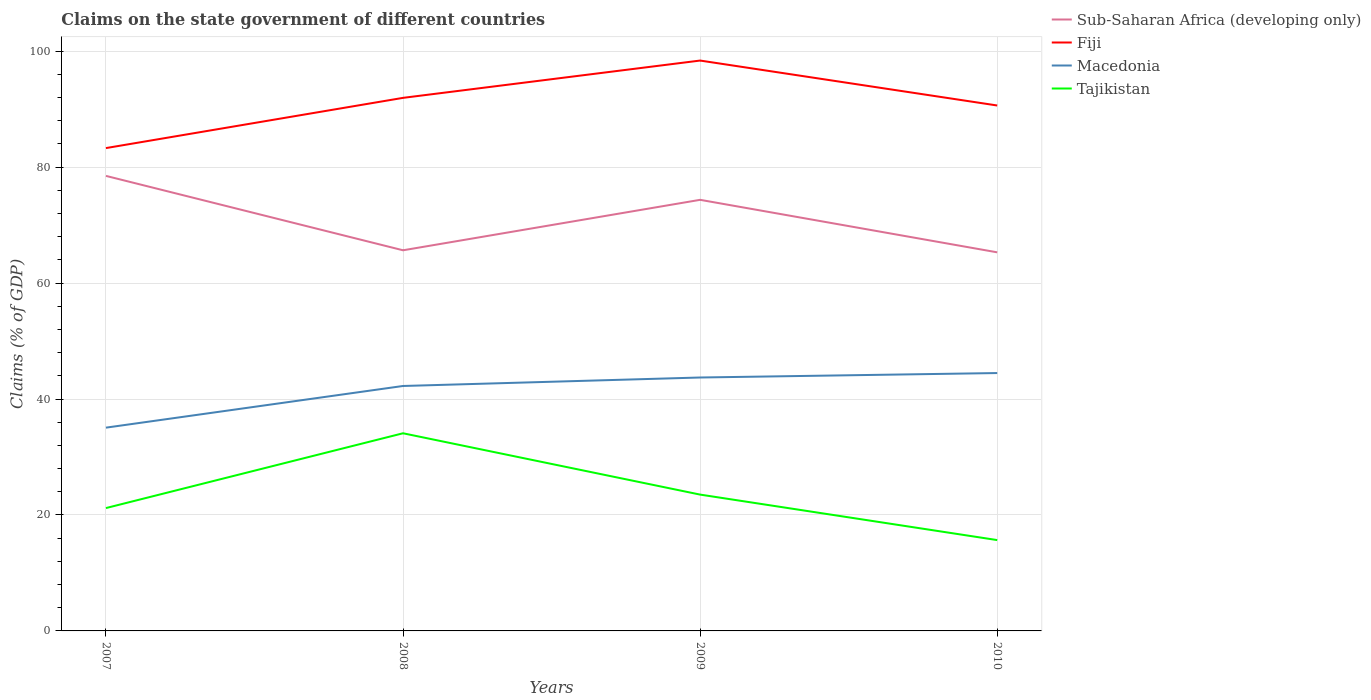Does the line corresponding to Macedonia intersect with the line corresponding to Tajikistan?
Your answer should be very brief. No. Across all years, what is the maximum percentage of GDP claimed on the state government in Fiji?
Offer a terse response. 83.28. What is the total percentage of GDP claimed on the state government in Sub-Saharan Africa (developing only) in the graph?
Give a very brief answer. 13.18. What is the difference between the highest and the second highest percentage of GDP claimed on the state government in Fiji?
Ensure brevity in your answer.  15.1. Is the percentage of GDP claimed on the state government in Fiji strictly greater than the percentage of GDP claimed on the state government in Macedonia over the years?
Provide a short and direct response. No. How many years are there in the graph?
Provide a short and direct response. 4. What is the difference between two consecutive major ticks on the Y-axis?
Offer a terse response. 20. Are the values on the major ticks of Y-axis written in scientific E-notation?
Provide a short and direct response. No. Does the graph contain any zero values?
Keep it short and to the point. No. Where does the legend appear in the graph?
Make the answer very short. Top right. How are the legend labels stacked?
Ensure brevity in your answer.  Vertical. What is the title of the graph?
Offer a very short reply. Claims on the state government of different countries. Does "Barbados" appear as one of the legend labels in the graph?
Your answer should be very brief. No. What is the label or title of the X-axis?
Your answer should be compact. Years. What is the label or title of the Y-axis?
Your answer should be very brief. Claims (% of GDP). What is the Claims (% of GDP) of Sub-Saharan Africa (developing only) in 2007?
Your answer should be compact. 78.48. What is the Claims (% of GDP) in Fiji in 2007?
Make the answer very short. 83.28. What is the Claims (% of GDP) in Macedonia in 2007?
Your answer should be compact. 35.06. What is the Claims (% of GDP) of Tajikistan in 2007?
Provide a succinct answer. 21.19. What is the Claims (% of GDP) in Sub-Saharan Africa (developing only) in 2008?
Give a very brief answer. 65.65. What is the Claims (% of GDP) of Fiji in 2008?
Keep it short and to the point. 91.94. What is the Claims (% of GDP) in Macedonia in 2008?
Make the answer very short. 42.25. What is the Claims (% of GDP) of Tajikistan in 2008?
Your answer should be very brief. 34.09. What is the Claims (% of GDP) of Sub-Saharan Africa (developing only) in 2009?
Keep it short and to the point. 74.35. What is the Claims (% of GDP) of Fiji in 2009?
Offer a terse response. 98.38. What is the Claims (% of GDP) in Macedonia in 2009?
Keep it short and to the point. 43.71. What is the Claims (% of GDP) in Tajikistan in 2009?
Your answer should be compact. 23.51. What is the Claims (% of GDP) of Sub-Saharan Africa (developing only) in 2010?
Provide a short and direct response. 65.3. What is the Claims (% of GDP) in Fiji in 2010?
Ensure brevity in your answer.  90.63. What is the Claims (% of GDP) of Macedonia in 2010?
Offer a terse response. 44.48. What is the Claims (% of GDP) of Tajikistan in 2010?
Keep it short and to the point. 15.67. Across all years, what is the maximum Claims (% of GDP) in Sub-Saharan Africa (developing only)?
Offer a terse response. 78.48. Across all years, what is the maximum Claims (% of GDP) of Fiji?
Give a very brief answer. 98.38. Across all years, what is the maximum Claims (% of GDP) in Macedonia?
Keep it short and to the point. 44.48. Across all years, what is the maximum Claims (% of GDP) in Tajikistan?
Your answer should be very brief. 34.09. Across all years, what is the minimum Claims (% of GDP) of Sub-Saharan Africa (developing only)?
Keep it short and to the point. 65.3. Across all years, what is the minimum Claims (% of GDP) of Fiji?
Make the answer very short. 83.28. Across all years, what is the minimum Claims (% of GDP) of Macedonia?
Your answer should be very brief. 35.06. Across all years, what is the minimum Claims (% of GDP) in Tajikistan?
Give a very brief answer. 15.67. What is the total Claims (% of GDP) of Sub-Saharan Africa (developing only) in the graph?
Provide a succinct answer. 283.79. What is the total Claims (% of GDP) in Fiji in the graph?
Your response must be concise. 364.22. What is the total Claims (% of GDP) in Macedonia in the graph?
Give a very brief answer. 165.49. What is the total Claims (% of GDP) of Tajikistan in the graph?
Ensure brevity in your answer.  94.46. What is the difference between the Claims (% of GDP) in Sub-Saharan Africa (developing only) in 2007 and that in 2008?
Provide a short and direct response. 12.83. What is the difference between the Claims (% of GDP) in Fiji in 2007 and that in 2008?
Your response must be concise. -8.66. What is the difference between the Claims (% of GDP) in Macedonia in 2007 and that in 2008?
Make the answer very short. -7.19. What is the difference between the Claims (% of GDP) in Sub-Saharan Africa (developing only) in 2007 and that in 2009?
Your answer should be compact. 4.13. What is the difference between the Claims (% of GDP) in Fiji in 2007 and that in 2009?
Offer a very short reply. -15.1. What is the difference between the Claims (% of GDP) in Macedonia in 2007 and that in 2009?
Provide a succinct answer. -8.65. What is the difference between the Claims (% of GDP) in Tajikistan in 2007 and that in 2009?
Offer a very short reply. -2.32. What is the difference between the Claims (% of GDP) in Sub-Saharan Africa (developing only) in 2007 and that in 2010?
Your answer should be very brief. 13.18. What is the difference between the Claims (% of GDP) in Fiji in 2007 and that in 2010?
Provide a succinct answer. -7.35. What is the difference between the Claims (% of GDP) of Macedonia in 2007 and that in 2010?
Make the answer very short. -9.42. What is the difference between the Claims (% of GDP) in Tajikistan in 2007 and that in 2010?
Provide a short and direct response. 5.52. What is the difference between the Claims (% of GDP) of Sub-Saharan Africa (developing only) in 2008 and that in 2009?
Keep it short and to the point. -8.7. What is the difference between the Claims (% of GDP) of Fiji in 2008 and that in 2009?
Offer a very short reply. -6.43. What is the difference between the Claims (% of GDP) of Macedonia in 2008 and that in 2009?
Offer a very short reply. -1.46. What is the difference between the Claims (% of GDP) in Tajikistan in 2008 and that in 2009?
Your answer should be compact. 10.58. What is the difference between the Claims (% of GDP) in Sub-Saharan Africa (developing only) in 2008 and that in 2010?
Your answer should be very brief. 0.35. What is the difference between the Claims (% of GDP) of Fiji in 2008 and that in 2010?
Your answer should be very brief. 1.32. What is the difference between the Claims (% of GDP) of Macedonia in 2008 and that in 2010?
Make the answer very short. -2.23. What is the difference between the Claims (% of GDP) in Tajikistan in 2008 and that in 2010?
Make the answer very short. 18.42. What is the difference between the Claims (% of GDP) in Sub-Saharan Africa (developing only) in 2009 and that in 2010?
Give a very brief answer. 9.06. What is the difference between the Claims (% of GDP) in Fiji in 2009 and that in 2010?
Your answer should be compact. 7.75. What is the difference between the Claims (% of GDP) in Macedonia in 2009 and that in 2010?
Offer a very short reply. -0.77. What is the difference between the Claims (% of GDP) of Tajikistan in 2009 and that in 2010?
Your response must be concise. 7.85. What is the difference between the Claims (% of GDP) of Sub-Saharan Africa (developing only) in 2007 and the Claims (% of GDP) of Fiji in 2008?
Give a very brief answer. -13.46. What is the difference between the Claims (% of GDP) of Sub-Saharan Africa (developing only) in 2007 and the Claims (% of GDP) of Macedonia in 2008?
Make the answer very short. 36.23. What is the difference between the Claims (% of GDP) of Sub-Saharan Africa (developing only) in 2007 and the Claims (% of GDP) of Tajikistan in 2008?
Ensure brevity in your answer.  44.39. What is the difference between the Claims (% of GDP) of Fiji in 2007 and the Claims (% of GDP) of Macedonia in 2008?
Ensure brevity in your answer.  41.03. What is the difference between the Claims (% of GDP) in Fiji in 2007 and the Claims (% of GDP) in Tajikistan in 2008?
Your answer should be compact. 49.19. What is the difference between the Claims (% of GDP) in Macedonia in 2007 and the Claims (% of GDP) in Tajikistan in 2008?
Your answer should be compact. 0.97. What is the difference between the Claims (% of GDP) of Sub-Saharan Africa (developing only) in 2007 and the Claims (% of GDP) of Fiji in 2009?
Provide a succinct answer. -19.89. What is the difference between the Claims (% of GDP) of Sub-Saharan Africa (developing only) in 2007 and the Claims (% of GDP) of Macedonia in 2009?
Your response must be concise. 34.77. What is the difference between the Claims (% of GDP) of Sub-Saharan Africa (developing only) in 2007 and the Claims (% of GDP) of Tajikistan in 2009?
Keep it short and to the point. 54.97. What is the difference between the Claims (% of GDP) of Fiji in 2007 and the Claims (% of GDP) of Macedonia in 2009?
Ensure brevity in your answer.  39.57. What is the difference between the Claims (% of GDP) in Fiji in 2007 and the Claims (% of GDP) in Tajikistan in 2009?
Provide a short and direct response. 59.77. What is the difference between the Claims (% of GDP) of Macedonia in 2007 and the Claims (% of GDP) of Tajikistan in 2009?
Keep it short and to the point. 11.55. What is the difference between the Claims (% of GDP) in Sub-Saharan Africa (developing only) in 2007 and the Claims (% of GDP) in Fiji in 2010?
Provide a succinct answer. -12.14. What is the difference between the Claims (% of GDP) of Sub-Saharan Africa (developing only) in 2007 and the Claims (% of GDP) of Macedonia in 2010?
Your response must be concise. 34. What is the difference between the Claims (% of GDP) of Sub-Saharan Africa (developing only) in 2007 and the Claims (% of GDP) of Tajikistan in 2010?
Make the answer very short. 62.81. What is the difference between the Claims (% of GDP) in Fiji in 2007 and the Claims (% of GDP) in Macedonia in 2010?
Give a very brief answer. 38.8. What is the difference between the Claims (% of GDP) of Fiji in 2007 and the Claims (% of GDP) of Tajikistan in 2010?
Your answer should be very brief. 67.61. What is the difference between the Claims (% of GDP) of Macedonia in 2007 and the Claims (% of GDP) of Tajikistan in 2010?
Provide a succinct answer. 19.39. What is the difference between the Claims (% of GDP) in Sub-Saharan Africa (developing only) in 2008 and the Claims (% of GDP) in Fiji in 2009?
Your response must be concise. -32.72. What is the difference between the Claims (% of GDP) of Sub-Saharan Africa (developing only) in 2008 and the Claims (% of GDP) of Macedonia in 2009?
Offer a terse response. 21.94. What is the difference between the Claims (% of GDP) of Sub-Saharan Africa (developing only) in 2008 and the Claims (% of GDP) of Tajikistan in 2009?
Give a very brief answer. 42.14. What is the difference between the Claims (% of GDP) of Fiji in 2008 and the Claims (% of GDP) of Macedonia in 2009?
Your answer should be compact. 48.23. What is the difference between the Claims (% of GDP) of Fiji in 2008 and the Claims (% of GDP) of Tajikistan in 2009?
Keep it short and to the point. 68.43. What is the difference between the Claims (% of GDP) of Macedonia in 2008 and the Claims (% of GDP) of Tajikistan in 2009?
Your response must be concise. 18.73. What is the difference between the Claims (% of GDP) of Sub-Saharan Africa (developing only) in 2008 and the Claims (% of GDP) of Fiji in 2010?
Your response must be concise. -24.97. What is the difference between the Claims (% of GDP) of Sub-Saharan Africa (developing only) in 2008 and the Claims (% of GDP) of Macedonia in 2010?
Ensure brevity in your answer.  21.18. What is the difference between the Claims (% of GDP) in Sub-Saharan Africa (developing only) in 2008 and the Claims (% of GDP) in Tajikistan in 2010?
Offer a terse response. 49.99. What is the difference between the Claims (% of GDP) of Fiji in 2008 and the Claims (% of GDP) of Macedonia in 2010?
Give a very brief answer. 47.46. What is the difference between the Claims (% of GDP) of Fiji in 2008 and the Claims (% of GDP) of Tajikistan in 2010?
Give a very brief answer. 76.28. What is the difference between the Claims (% of GDP) in Macedonia in 2008 and the Claims (% of GDP) in Tajikistan in 2010?
Provide a succinct answer. 26.58. What is the difference between the Claims (% of GDP) of Sub-Saharan Africa (developing only) in 2009 and the Claims (% of GDP) of Fiji in 2010?
Provide a succinct answer. -16.27. What is the difference between the Claims (% of GDP) in Sub-Saharan Africa (developing only) in 2009 and the Claims (% of GDP) in Macedonia in 2010?
Your answer should be compact. 29.88. What is the difference between the Claims (% of GDP) in Sub-Saharan Africa (developing only) in 2009 and the Claims (% of GDP) in Tajikistan in 2010?
Keep it short and to the point. 58.69. What is the difference between the Claims (% of GDP) in Fiji in 2009 and the Claims (% of GDP) in Macedonia in 2010?
Your answer should be very brief. 53.9. What is the difference between the Claims (% of GDP) of Fiji in 2009 and the Claims (% of GDP) of Tajikistan in 2010?
Provide a succinct answer. 82.71. What is the difference between the Claims (% of GDP) in Macedonia in 2009 and the Claims (% of GDP) in Tajikistan in 2010?
Offer a very short reply. 28.04. What is the average Claims (% of GDP) of Sub-Saharan Africa (developing only) per year?
Provide a succinct answer. 70.95. What is the average Claims (% of GDP) in Fiji per year?
Your response must be concise. 91.06. What is the average Claims (% of GDP) of Macedonia per year?
Your response must be concise. 41.37. What is the average Claims (% of GDP) of Tajikistan per year?
Your answer should be compact. 23.61. In the year 2007, what is the difference between the Claims (% of GDP) of Sub-Saharan Africa (developing only) and Claims (% of GDP) of Fiji?
Offer a terse response. -4.8. In the year 2007, what is the difference between the Claims (% of GDP) of Sub-Saharan Africa (developing only) and Claims (% of GDP) of Macedonia?
Provide a succinct answer. 43.42. In the year 2007, what is the difference between the Claims (% of GDP) in Sub-Saharan Africa (developing only) and Claims (% of GDP) in Tajikistan?
Your answer should be very brief. 57.29. In the year 2007, what is the difference between the Claims (% of GDP) in Fiji and Claims (% of GDP) in Macedonia?
Your answer should be compact. 48.22. In the year 2007, what is the difference between the Claims (% of GDP) of Fiji and Claims (% of GDP) of Tajikistan?
Provide a succinct answer. 62.09. In the year 2007, what is the difference between the Claims (% of GDP) in Macedonia and Claims (% of GDP) in Tajikistan?
Keep it short and to the point. 13.87. In the year 2008, what is the difference between the Claims (% of GDP) of Sub-Saharan Africa (developing only) and Claims (% of GDP) of Fiji?
Provide a short and direct response. -26.29. In the year 2008, what is the difference between the Claims (% of GDP) in Sub-Saharan Africa (developing only) and Claims (% of GDP) in Macedonia?
Provide a succinct answer. 23.41. In the year 2008, what is the difference between the Claims (% of GDP) in Sub-Saharan Africa (developing only) and Claims (% of GDP) in Tajikistan?
Provide a succinct answer. 31.56. In the year 2008, what is the difference between the Claims (% of GDP) in Fiji and Claims (% of GDP) in Macedonia?
Your answer should be compact. 49.69. In the year 2008, what is the difference between the Claims (% of GDP) of Fiji and Claims (% of GDP) of Tajikistan?
Your answer should be very brief. 57.85. In the year 2008, what is the difference between the Claims (% of GDP) of Macedonia and Claims (% of GDP) of Tajikistan?
Offer a terse response. 8.16. In the year 2009, what is the difference between the Claims (% of GDP) of Sub-Saharan Africa (developing only) and Claims (% of GDP) of Fiji?
Offer a very short reply. -24.02. In the year 2009, what is the difference between the Claims (% of GDP) of Sub-Saharan Africa (developing only) and Claims (% of GDP) of Macedonia?
Your answer should be very brief. 30.64. In the year 2009, what is the difference between the Claims (% of GDP) in Sub-Saharan Africa (developing only) and Claims (% of GDP) in Tajikistan?
Provide a succinct answer. 50.84. In the year 2009, what is the difference between the Claims (% of GDP) of Fiji and Claims (% of GDP) of Macedonia?
Your answer should be very brief. 54.67. In the year 2009, what is the difference between the Claims (% of GDP) of Fiji and Claims (% of GDP) of Tajikistan?
Give a very brief answer. 74.86. In the year 2009, what is the difference between the Claims (% of GDP) of Macedonia and Claims (% of GDP) of Tajikistan?
Your answer should be compact. 20.2. In the year 2010, what is the difference between the Claims (% of GDP) in Sub-Saharan Africa (developing only) and Claims (% of GDP) in Fiji?
Your answer should be compact. -25.33. In the year 2010, what is the difference between the Claims (% of GDP) in Sub-Saharan Africa (developing only) and Claims (% of GDP) in Macedonia?
Ensure brevity in your answer.  20.82. In the year 2010, what is the difference between the Claims (% of GDP) in Sub-Saharan Africa (developing only) and Claims (% of GDP) in Tajikistan?
Ensure brevity in your answer.  49.63. In the year 2010, what is the difference between the Claims (% of GDP) in Fiji and Claims (% of GDP) in Macedonia?
Offer a very short reply. 46.15. In the year 2010, what is the difference between the Claims (% of GDP) in Fiji and Claims (% of GDP) in Tajikistan?
Provide a short and direct response. 74.96. In the year 2010, what is the difference between the Claims (% of GDP) of Macedonia and Claims (% of GDP) of Tajikistan?
Provide a short and direct response. 28.81. What is the ratio of the Claims (% of GDP) in Sub-Saharan Africa (developing only) in 2007 to that in 2008?
Offer a terse response. 1.2. What is the ratio of the Claims (% of GDP) of Fiji in 2007 to that in 2008?
Offer a terse response. 0.91. What is the ratio of the Claims (% of GDP) in Macedonia in 2007 to that in 2008?
Make the answer very short. 0.83. What is the ratio of the Claims (% of GDP) of Tajikistan in 2007 to that in 2008?
Your answer should be compact. 0.62. What is the ratio of the Claims (% of GDP) in Sub-Saharan Africa (developing only) in 2007 to that in 2009?
Provide a short and direct response. 1.06. What is the ratio of the Claims (% of GDP) of Fiji in 2007 to that in 2009?
Your answer should be very brief. 0.85. What is the ratio of the Claims (% of GDP) of Macedonia in 2007 to that in 2009?
Offer a very short reply. 0.8. What is the ratio of the Claims (% of GDP) of Tajikistan in 2007 to that in 2009?
Ensure brevity in your answer.  0.9. What is the ratio of the Claims (% of GDP) of Sub-Saharan Africa (developing only) in 2007 to that in 2010?
Your answer should be very brief. 1.2. What is the ratio of the Claims (% of GDP) in Fiji in 2007 to that in 2010?
Offer a very short reply. 0.92. What is the ratio of the Claims (% of GDP) of Macedonia in 2007 to that in 2010?
Your answer should be compact. 0.79. What is the ratio of the Claims (% of GDP) in Tajikistan in 2007 to that in 2010?
Give a very brief answer. 1.35. What is the ratio of the Claims (% of GDP) of Sub-Saharan Africa (developing only) in 2008 to that in 2009?
Make the answer very short. 0.88. What is the ratio of the Claims (% of GDP) in Fiji in 2008 to that in 2009?
Give a very brief answer. 0.93. What is the ratio of the Claims (% of GDP) of Macedonia in 2008 to that in 2009?
Provide a succinct answer. 0.97. What is the ratio of the Claims (% of GDP) in Tajikistan in 2008 to that in 2009?
Keep it short and to the point. 1.45. What is the ratio of the Claims (% of GDP) of Sub-Saharan Africa (developing only) in 2008 to that in 2010?
Ensure brevity in your answer.  1.01. What is the ratio of the Claims (% of GDP) of Fiji in 2008 to that in 2010?
Keep it short and to the point. 1.01. What is the ratio of the Claims (% of GDP) of Macedonia in 2008 to that in 2010?
Offer a terse response. 0.95. What is the ratio of the Claims (% of GDP) of Tajikistan in 2008 to that in 2010?
Offer a terse response. 2.18. What is the ratio of the Claims (% of GDP) in Sub-Saharan Africa (developing only) in 2009 to that in 2010?
Give a very brief answer. 1.14. What is the ratio of the Claims (% of GDP) in Fiji in 2009 to that in 2010?
Keep it short and to the point. 1.09. What is the ratio of the Claims (% of GDP) of Macedonia in 2009 to that in 2010?
Your answer should be compact. 0.98. What is the ratio of the Claims (% of GDP) in Tajikistan in 2009 to that in 2010?
Make the answer very short. 1.5. What is the difference between the highest and the second highest Claims (% of GDP) of Sub-Saharan Africa (developing only)?
Your response must be concise. 4.13. What is the difference between the highest and the second highest Claims (% of GDP) of Fiji?
Provide a short and direct response. 6.43. What is the difference between the highest and the second highest Claims (% of GDP) in Macedonia?
Ensure brevity in your answer.  0.77. What is the difference between the highest and the second highest Claims (% of GDP) of Tajikistan?
Ensure brevity in your answer.  10.58. What is the difference between the highest and the lowest Claims (% of GDP) in Sub-Saharan Africa (developing only)?
Make the answer very short. 13.18. What is the difference between the highest and the lowest Claims (% of GDP) of Fiji?
Provide a short and direct response. 15.1. What is the difference between the highest and the lowest Claims (% of GDP) of Macedonia?
Give a very brief answer. 9.42. What is the difference between the highest and the lowest Claims (% of GDP) of Tajikistan?
Offer a terse response. 18.42. 